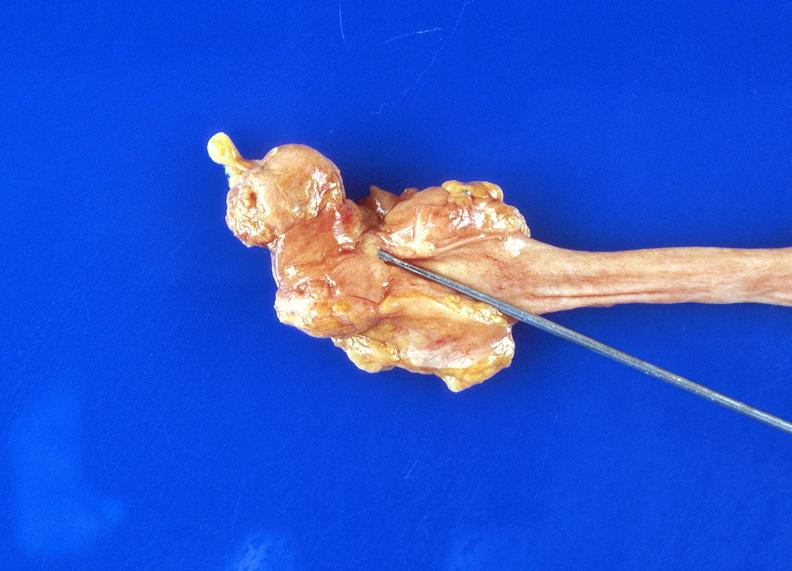what does this image show?
Answer the question using a single word or phrase. Ureteral stricture 